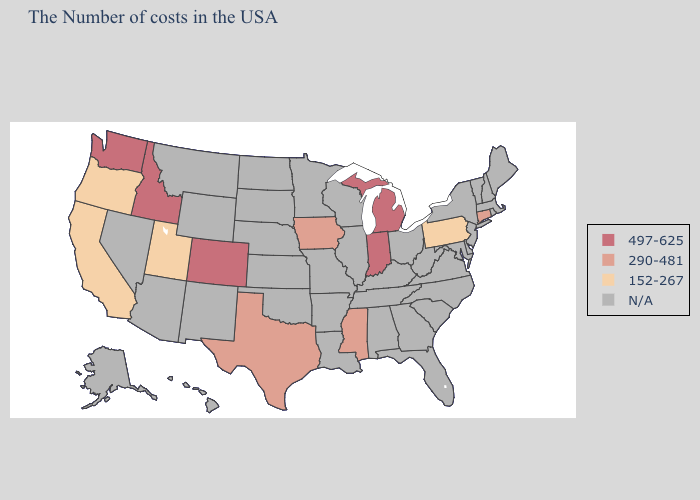What is the value of Utah?
Give a very brief answer. 152-267. Name the states that have a value in the range 497-625?
Keep it brief. Michigan, Indiana, Colorado, Idaho, Washington. What is the value of Nebraska?
Write a very short answer. N/A. What is the highest value in states that border Louisiana?
Be succinct. 290-481. Does Connecticut have the highest value in the Northeast?
Write a very short answer. Yes. Among the states that border Washington , does Oregon have the lowest value?
Write a very short answer. Yes. What is the value of Nebraska?
Write a very short answer. N/A. What is the lowest value in the South?
Give a very brief answer. 290-481. Which states have the highest value in the USA?
Give a very brief answer. Michigan, Indiana, Colorado, Idaho, Washington. 